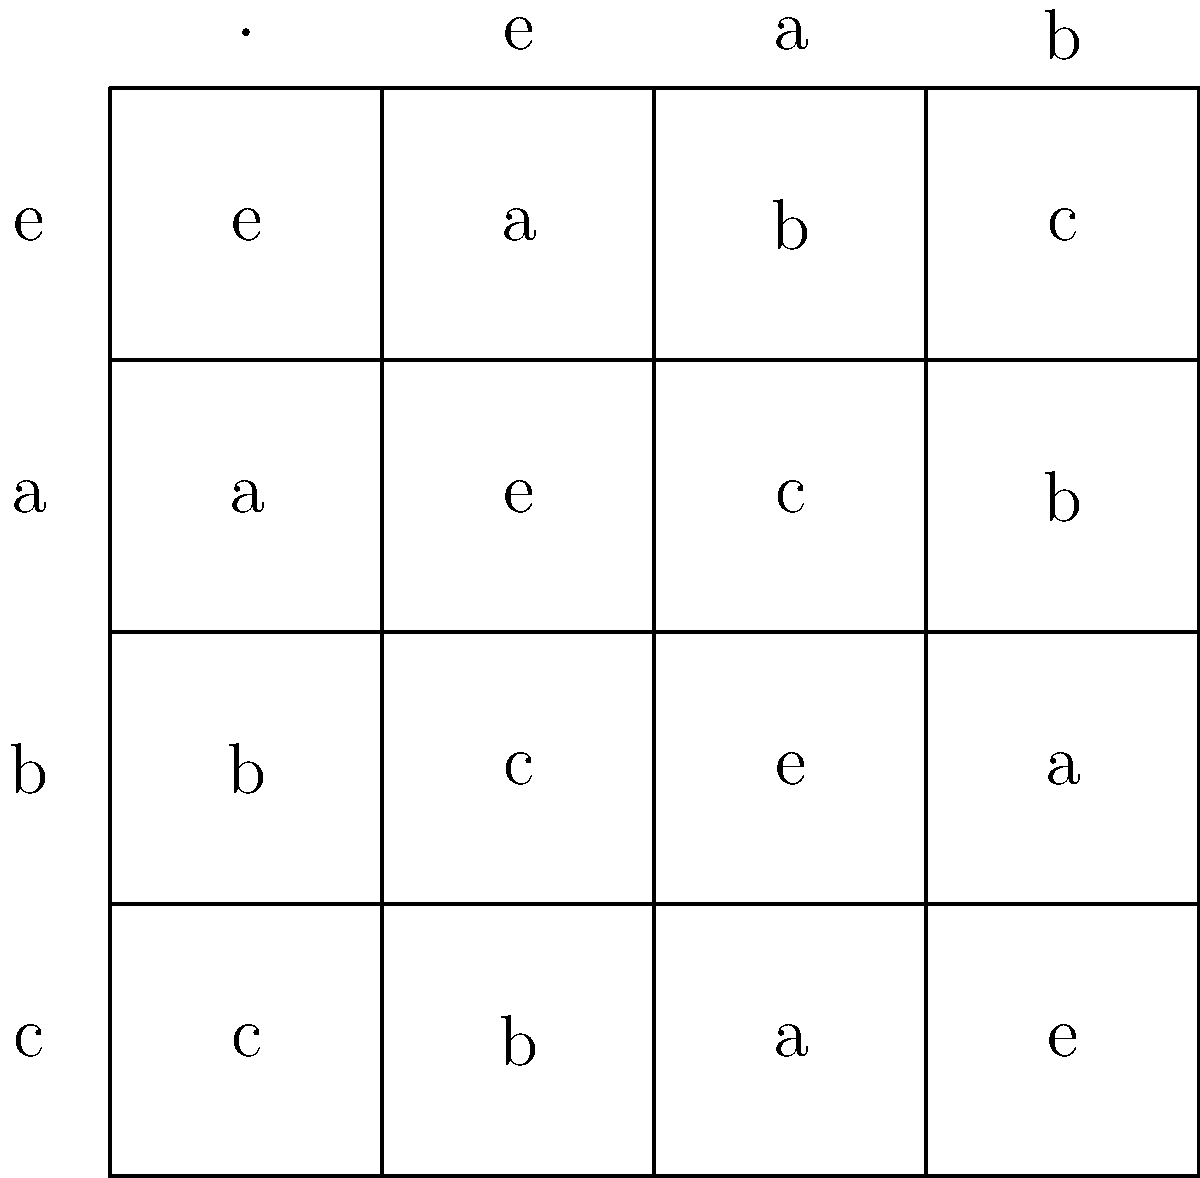Given the Cayley table for a group of order 4 shown above, determine the group's isomorphism class. Which well-known group is this isomorphic to, and what property of the table supports your conclusion? To determine the isomorphism class of this group, we need to analyze its structure:

1. First, note that the group has order 4, so it's either isomorphic to $C_4$ (cyclic group of order 4) or $V_4$ (Klein four-group).

2. Examine the elements' orders:
   - $e$ is the identity element (order 1)
   - $a^2 = e$, so $a$ has order 2
   - $b^2 = e$, so $b$ has order 2
   - $c^2 = e$, so $c$ has order 2

3. In $C_4$, there would be an element of order 4, but here all non-identity elements have order 2.

4. The key property to observe is that all non-identity elements are self-inverse (i.e., $a^2 = b^2 = c^2 = e$).

5. This is a characteristic property of the Klein four-group $V_4$.

6. Additionally, we can verify that the group is abelian (commutative) by checking that the table is symmetric about the main diagonal.

Therefore, this group is isomorphic to $V_4$, the Klein four-group. The property that supports this conclusion is that all non-identity elements are self-inverse and have order 2.
Answer: $V_4$ (Klein four-group); all non-identity elements are self-inverse. 